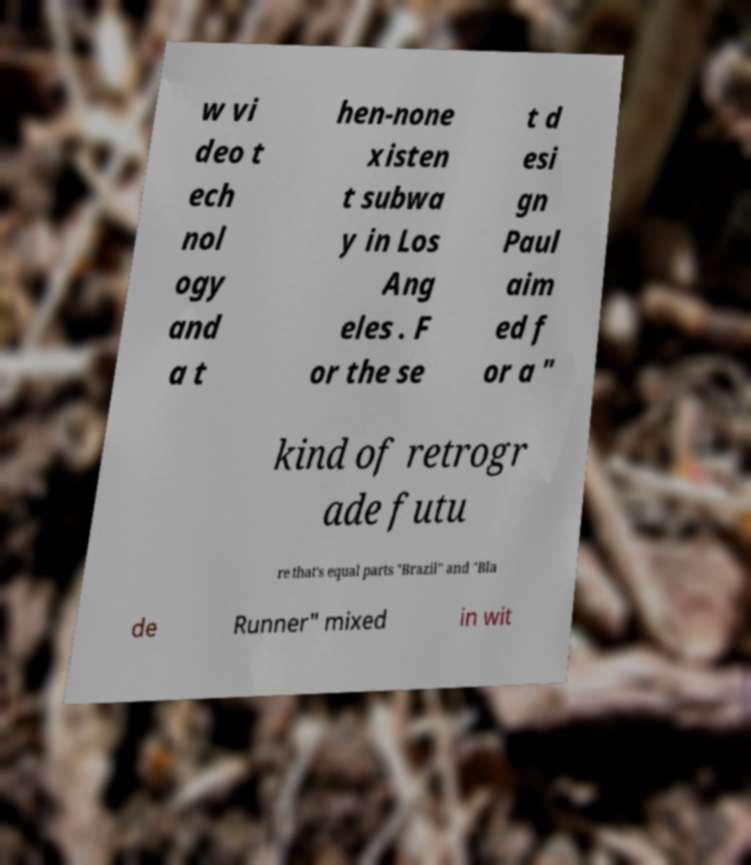There's text embedded in this image that I need extracted. Can you transcribe it verbatim? w vi deo t ech nol ogy and a t hen-none xisten t subwa y in Los Ang eles . F or the se t d esi gn Paul aim ed f or a " kind of retrogr ade futu re that's equal parts "Brazil" and "Bla de Runner" mixed in wit 